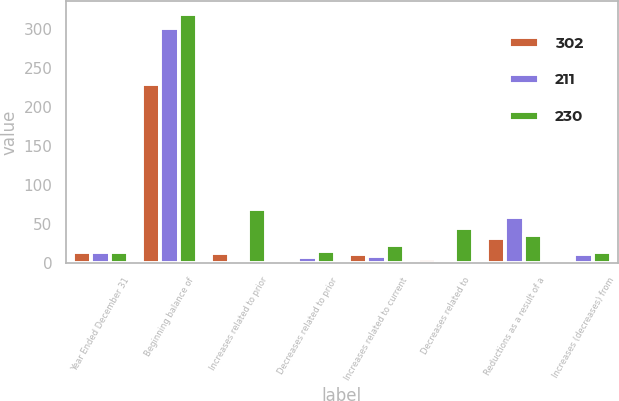Convert chart. <chart><loc_0><loc_0><loc_500><loc_500><stacked_bar_chart><ecel><fcel>Year Ended December 31<fcel>Beginning balance of<fcel>Increases related to prior<fcel>Decreases related to prior<fcel>Increases related to current<fcel>Decreases related to<fcel>Reductions as a result of a<fcel>Increases (decreases) from<nl><fcel>302<fcel>14<fcel>230<fcel>13<fcel>2<fcel>11<fcel>5<fcel>32<fcel>4<nl><fcel>211<fcel>14<fcel>302<fcel>1<fcel>7<fcel>8<fcel>4<fcel>59<fcel>11<nl><fcel>230<fcel>14<fcel>320<fcel>69<fcel>15<fcel>23<fcel>45<fcel>36<fcel>14<nl></chart> 